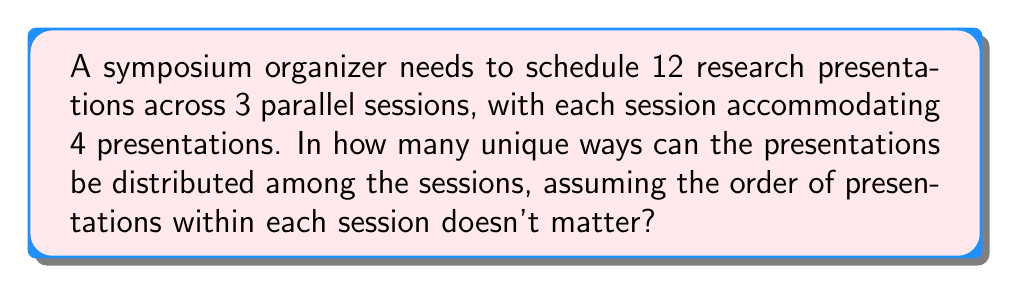Help me with this question. To solve this problem, we need to use the concept of combinations and the multiplication principle. Let's break it down step-by-step:

1. First, we need to choose 4 presentations for the first session out of 12. This can be done in $\binom{12}{4}$ ways.

2. After selecting the first 4, we have 8 presentations left, from which we need to choose 4 for the second session. This can be done in $\binom{8}{4}$ ways.

3. The remaining 4 presentations will automatically go to the third session.

4. However, this method counts each arrangement multiple times because the order of sessions doesn't matter. We need to divide by the number of ways to arrange 3 sessions, which is 3! = 6.

Therefore, the total number of unique ways to distribute the presentations is:

$$\frac{\binom{12}{4} \cdot \binom{8}{4}}{3!}$$

Let's calculate this:

$$\binom{12}{4} = \frac{12!}{4!(12-4)!} = \frac{12!}{4!8!} = 495$$

$$\binom{8}{4} = \frac{8!}{4!(8-4)!} = \frac{8!}{4!4!} = 70$$

Now, we can plug these values into our formula:

$$\frac{495 \cdot 70}{6} = \frac{34,650}{6} = 5,775$$
Answer: 5,775 unique ways 